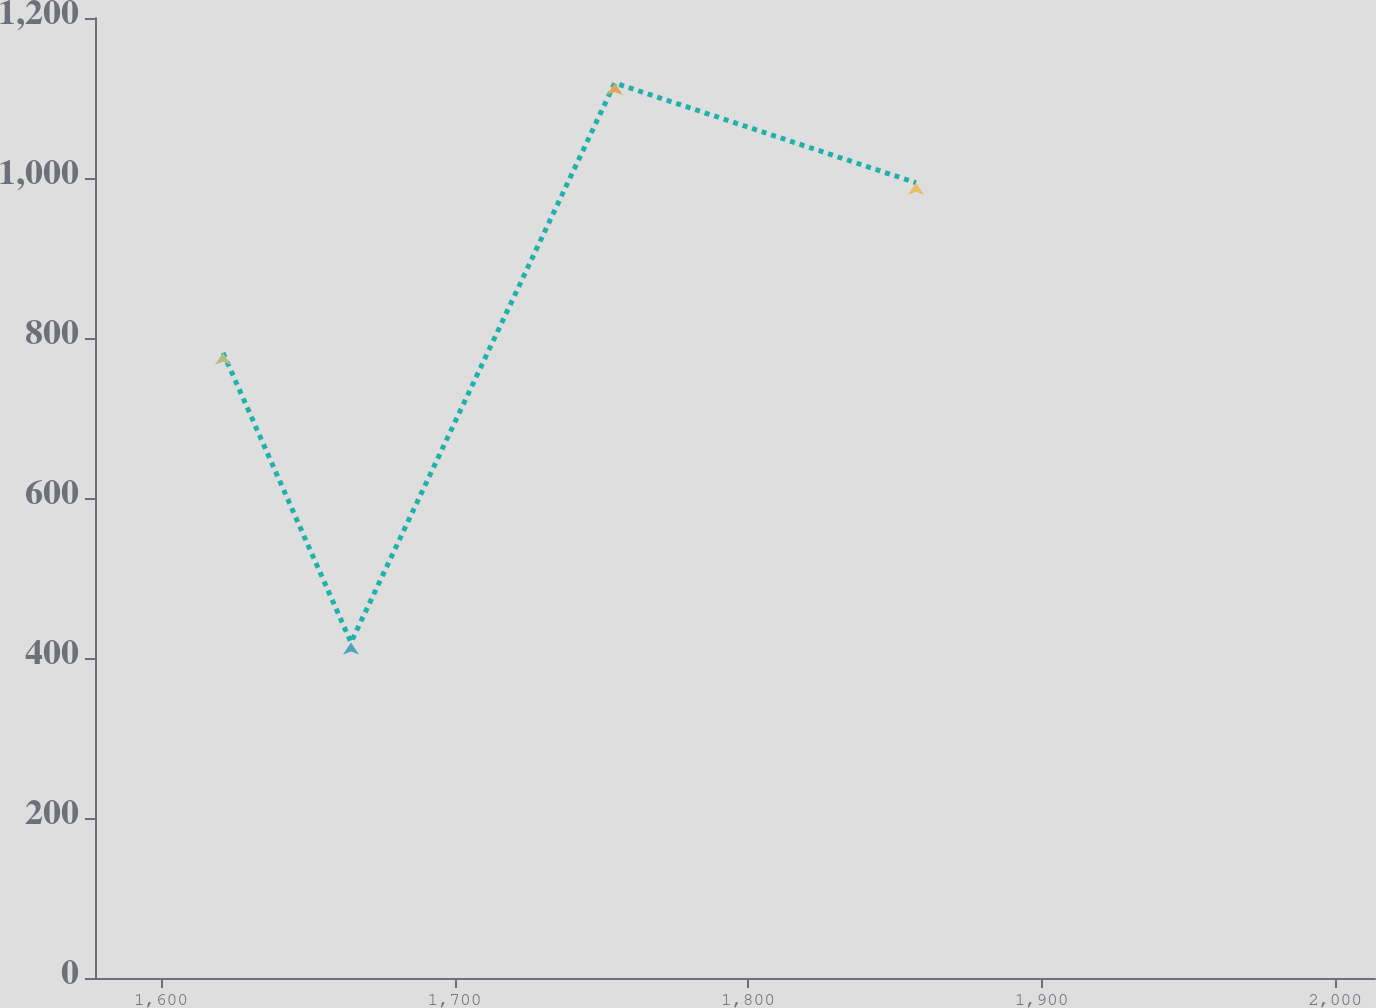<chart> <loc_0><loc_0><loc_500><loc_500><line_chart><ecel><fcel>Year Ending December 31<nl><fcel>1621.1<fcel>781.6<nl><fcel>1664.71<fcel>419.44<nl><fcel>1754.57<fcel>1118.78<nl><fcel>1857.21<fcel>994.04<nl><fcel>2057.18<fcel>1499.09<nl></chart> 